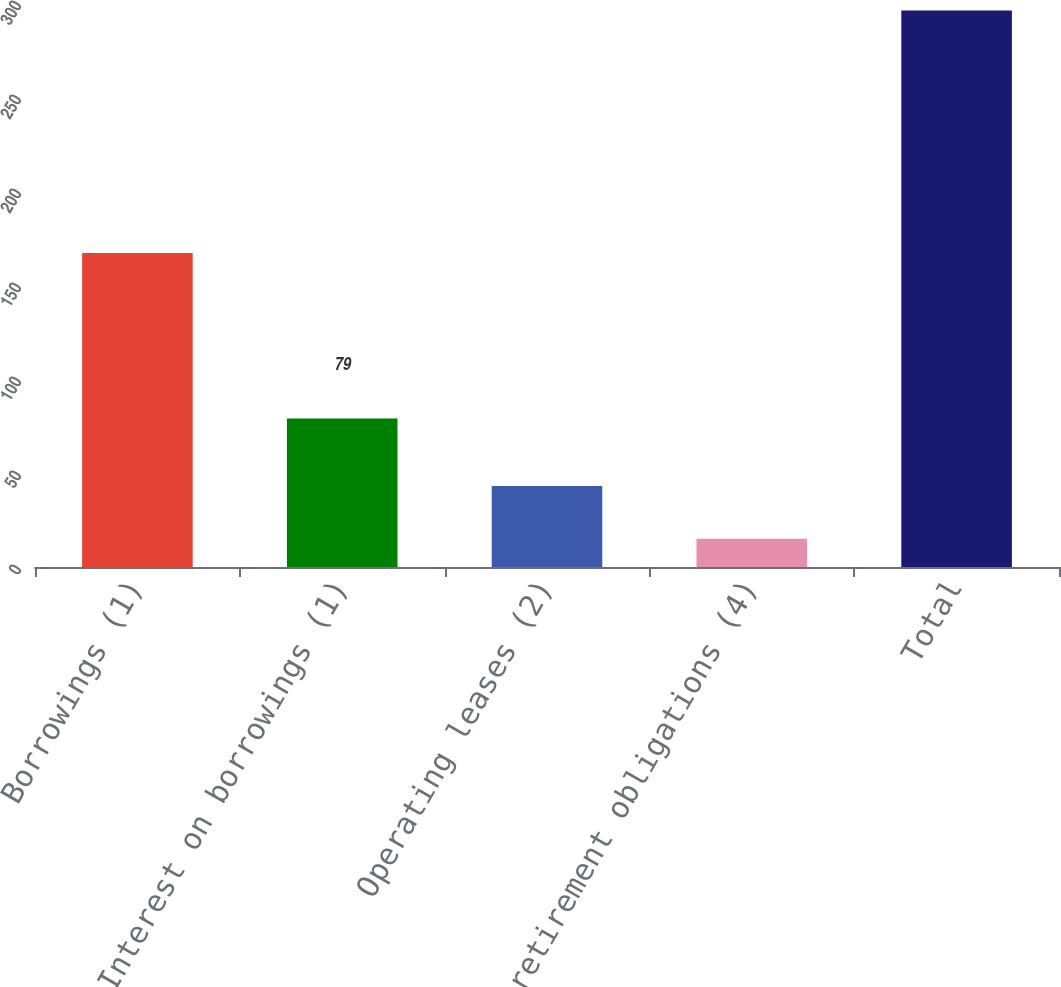Convert chart to OTSL. <chart><loc_0><loc_0><loc_500><loc_500><bar_chart><fcel>Borrowings (1)<fcel>Interest on borrowings (1)<fcel>Operating leases (2)<fcel>Postretirement obligations (4)<fcel>Total<nl><fcel>167<fcel>79<fcel>43.1<fcel>15<fcel>296<nl></chart> 